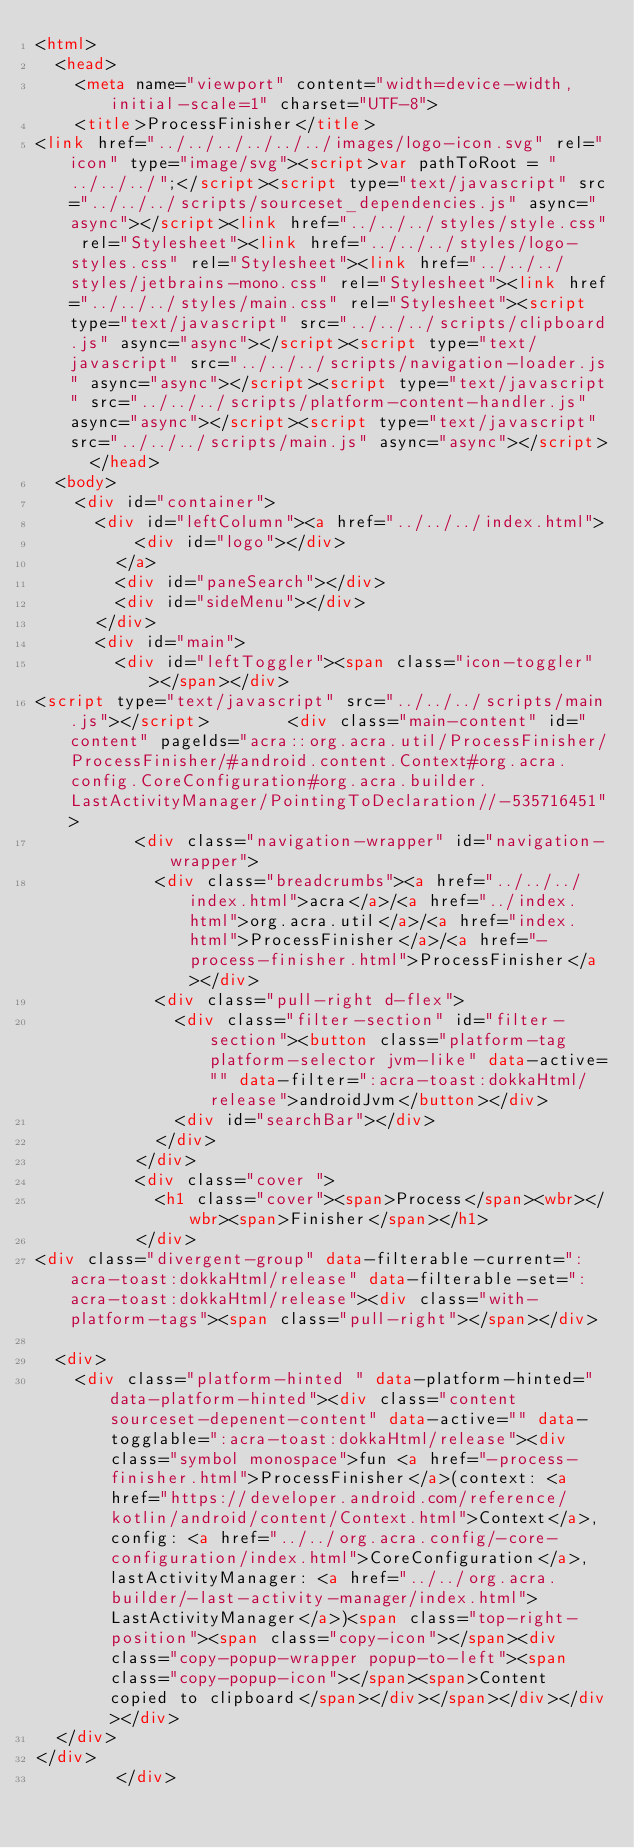Convert code to text. <code><loc_0><loc_0><loc_500><loc_500><_HTML_><html>
  <head>
    <meta name="viewport" content="width=device-width, initial-scale=1" charset="UTF-8">
    <title>ProcessFinisher</title>
<link href="../../../../../../images/logo-icon.svg" rel="icon" type="image/svg"><script>var pathToRoot = "../../../";</script><script type="text/javascript" src="../../../scripts/sourceset_dependencies.js" async="async"></script><link href="../../../styles/style.css" rel="Stylesheet"><link href="../../../styles/logo-styles.css" rel="Stylesheet"><link href="../../../styles/jetbrains-mono.css" rel="Stylesheet"><link href="../../../styles/main.css" rel="Stylesheet"><script type="text/javascript" src="../../../scripts/clipboard.js" async="async"></script><script type="text/javascript" src="../../../scripts/navigation-loader.js" async="async"></script><script type="text/javascript" src="../../../scripts/platform-content-handler.js" async="async"></script><script type="text/javascript" src="../../../scripts/main.js" async="async"></script>  </head>
  <body>
    <div id="container">
      <div id="leftColumn"><a href="../../../index.html">
          <div id="logo"></div>
        </a>
        <div id="paneSearch"></div>
        <div id="sideMenu"></div>
      </div>
      <div id="main">
        <div id="leftToggler"><span class="icon-toggler"></span></div>
<script type="text/javascript" src="../../../scripts/main.js"></script>        <div class="main-content" id="content" pageIds="acra::org.acra.util/ProcessFinisher/ProcessFinisher/#android.content.Context#org.acra.config.CoreConfiguration#org.acra.builder.LastActivityManager/PointingToDeclaration//-535716451">
          <div class="navigation-wrapper" id="navigation-wrapper">
            <div class="breadcrumbs"><a href="../../../index.html">acra</a>/<a href="../index.html">org.acra.util</a>/<a href="index.html">ProcessFinisher</a>/<a href="-process-finisher.html">ProcessFinisher</a></div>
            <div class="pull-right d-flex">
              <div class="filter-section" id="filter-section"><button class="platform-tag platform-selector jvm-like" data-active="" data-filter=":acra-toast:dokkaHtml/release">androidJvm</button></div>
              <div id="searchBar"></div>
            </div>
          </div>
          <div class="cover ">
            <h1 class="cover"><span>Process</span><wbr></wbr><span>Finisher</span></h1>
          </div>
<div class="divergent-group" data-filterable-current=":acra-toast:dokkaHtml/release" data-filterable-set=":acra-toast:dokkaHtml/release"><div class="with-platform-tags"><span class="pull-right"></span></div>

  <div>
    <div class="platform-hinted " data-platform-hinted="data-platform-hinted"><div class="content sourceset-depenent-content" data-active="" data-togglable=":acra-toast:dokkaHtml/release"><div class="symbol monospace">fun <a href="-process-finisher.html">ProcessFinisher</a>(context: <a href="https://developer.android.com/reference/kotlin/android/content/Context.html">Context</a>, config: <a href="../../org.acra.config/-core-configuration/index.html">CoreConfiguration</a>, lastActivityManager: <a href="../../org.acra.builder/-last-activity-manager/index.html">LastActivityManager</a>)<span class="top-right-position"><span class="copy-icon"></span><div class="copy-popup-wrapper popup-to-left"><span class="copy-popup-icon"></span><span>Content copied to clipboard</span></div></span></div></div></div>
  </div>
</div>
        </div></code> 